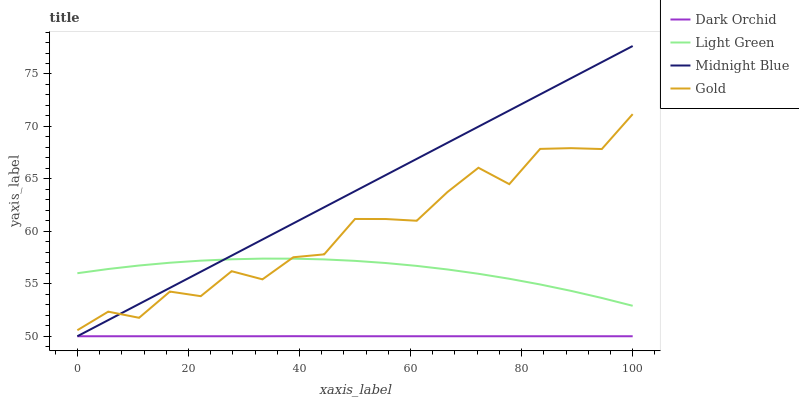Does Dark Orchid have the minimum area under the curve?
Answer yes or no. Yes. Does Midnight Blue have the maximum area under the curve?
Answer yes or no. Yes. Does Light Green have the minimum area under the curve?
Answer yes or no. No. Does Light Green have the maximum area under the curve?
Answer yes or no. No. Is Midnight Blue the smoothest?
Answer yes or no. Yes. Is Gold the roughest?
Answer yes or no. Yes. Is Light Green the smoothest?
Answer yes or no. No. Is Light Green the roughest?
Answer yes or no. No. Does Dark Orchid have the lowest value?
Answer yes or no. Yes. Does Light Green have the lowest value?
Answer yes or no. No. Does Midnight Blue have the highest value?
Answer yes or no. Yes. Does Light Green have the highest value?
Answer yes or no. No. Is Dark Orchid less than Gold?
Answer yes or no. Yes. Is Light Green greater than Dark Orchid?
Answer yes or no. Yes. Does Gold intersect Light Green?
Answer yes or no. Yes. Is Gold less than Light Green?
Answer yes or no. No. Is Gold greater than Light Green?
Answer yes or no. No. Does Dark Orchid intersect Gold?
Answer yes or no. No. 